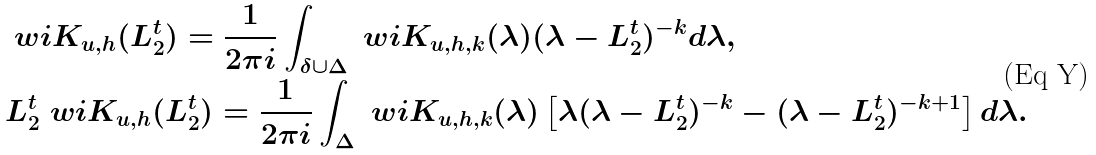<formula> <loc_0><loc_0><loc_500><loc_500>& \ w i { K } _ { u , h } ( L ^ { t } _ { 2 } ) = \frac { 1 } { 2 \pi i } \int _ { \delta \cup \Delta } \ w i { K } _ { u , h , k } ( \lambda ) ( \lambda - L ^ { t } _ { 2 } ) ^ { - k } d \lambda , \\ & L ^ { t } _ { 2 } \ w i { K } _ { u , h } ( L ^ { t } _ { 2 } ) = \frac { 1 } { 2 \pi i } \int _ { \Delta } \ w i { K } _ { u , h , k } ( \lambda ) \left [ \lambda ( \lambda - L ^ { t } _ { 2 } ) ^ { - k } - ( \lambda - L ^ { t } _ { 2 } ) ^ { - k + 1 } \right ] d \lambda .</formula> 